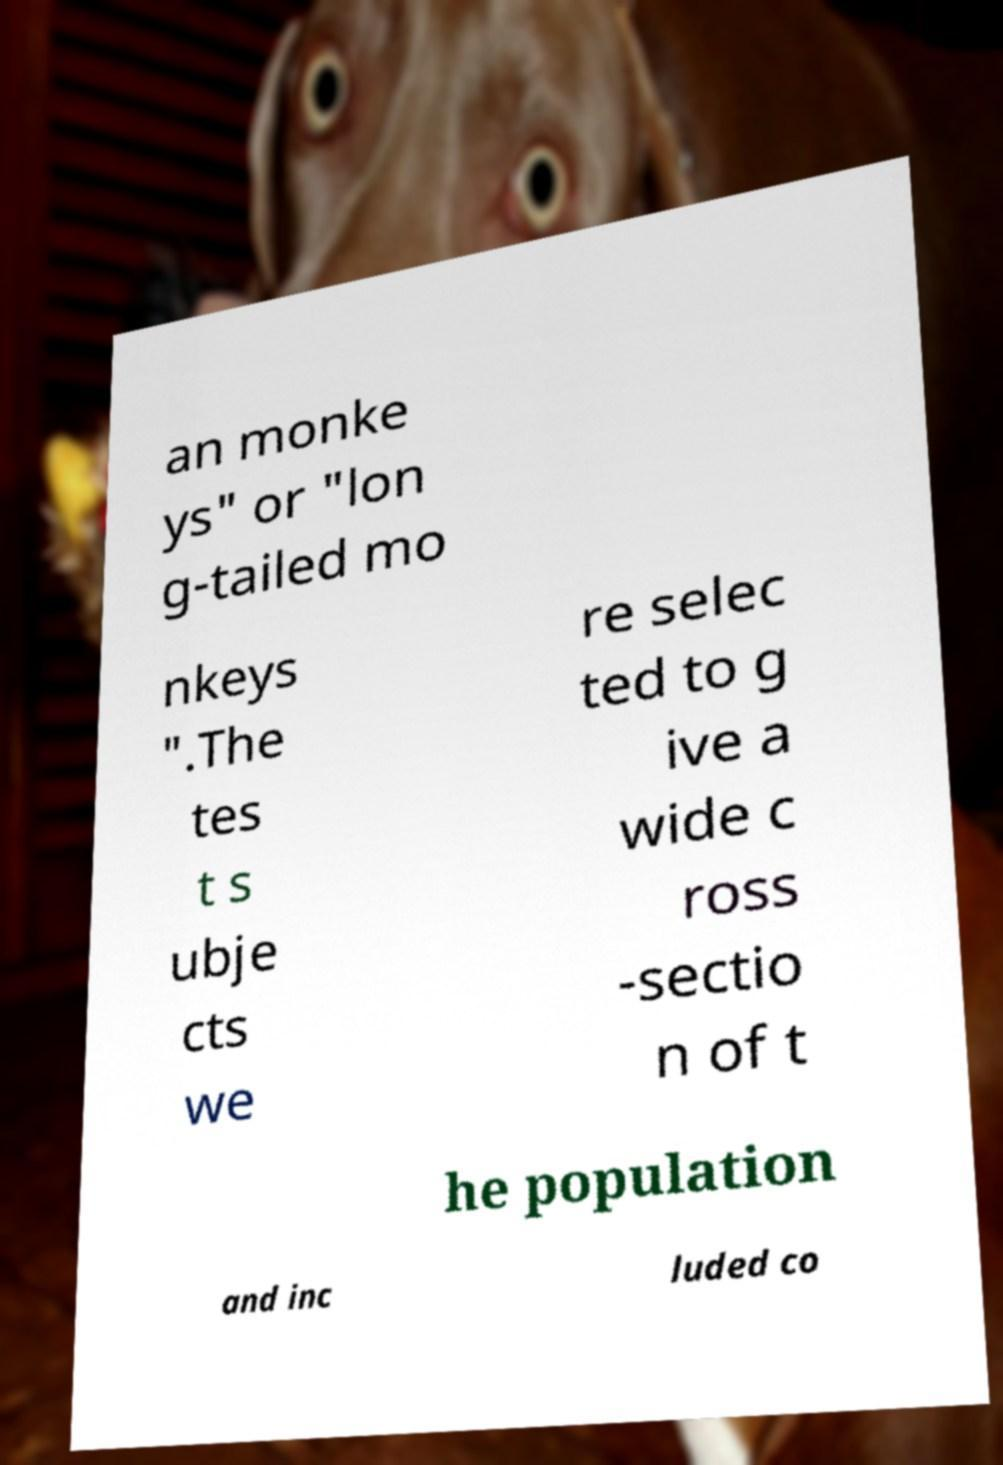Can you read and provide the text displayed in the image?This photo seems to have some interesting text. Can you extract and type it out for me? an monke ys" or "lon g-tailed mo nkeys ".The tes t s ubje cts we re selec ted to g ive a wide c ross -sectio n of t he population and inc luded co 